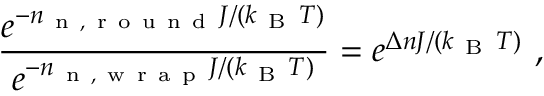Convert formula to latex. <formula><loc_0><loc_0><loc_500><loc_500>\frac { e ^ { - n _ { n , r o u n d } J / ( k _ { B } T ) } } { e ^ { - n _ { n , w r a p } J / ( k _ { B } T ) } } = e ^ { \Delta n J / ( k _ { B } T ) } \ ,</formula> 